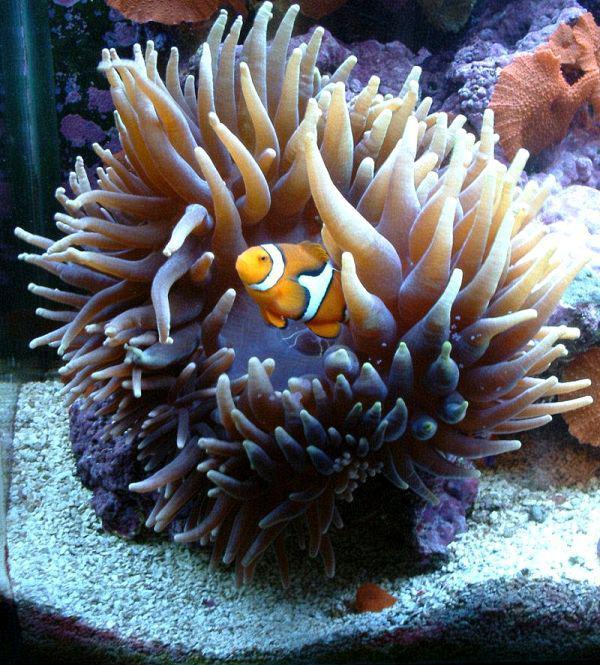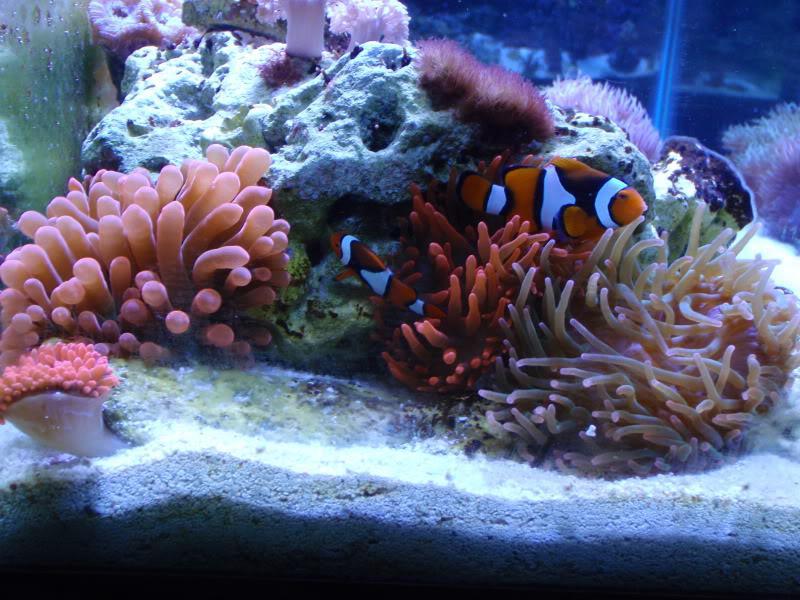The first image is the image on the left, the second image is the image on the right. Assess this claim about the two images: "There are orange, black and white stripe section on a single cloud fish that is in the arms of the corral.". Correct or not? Answer yes or no. Yes. 